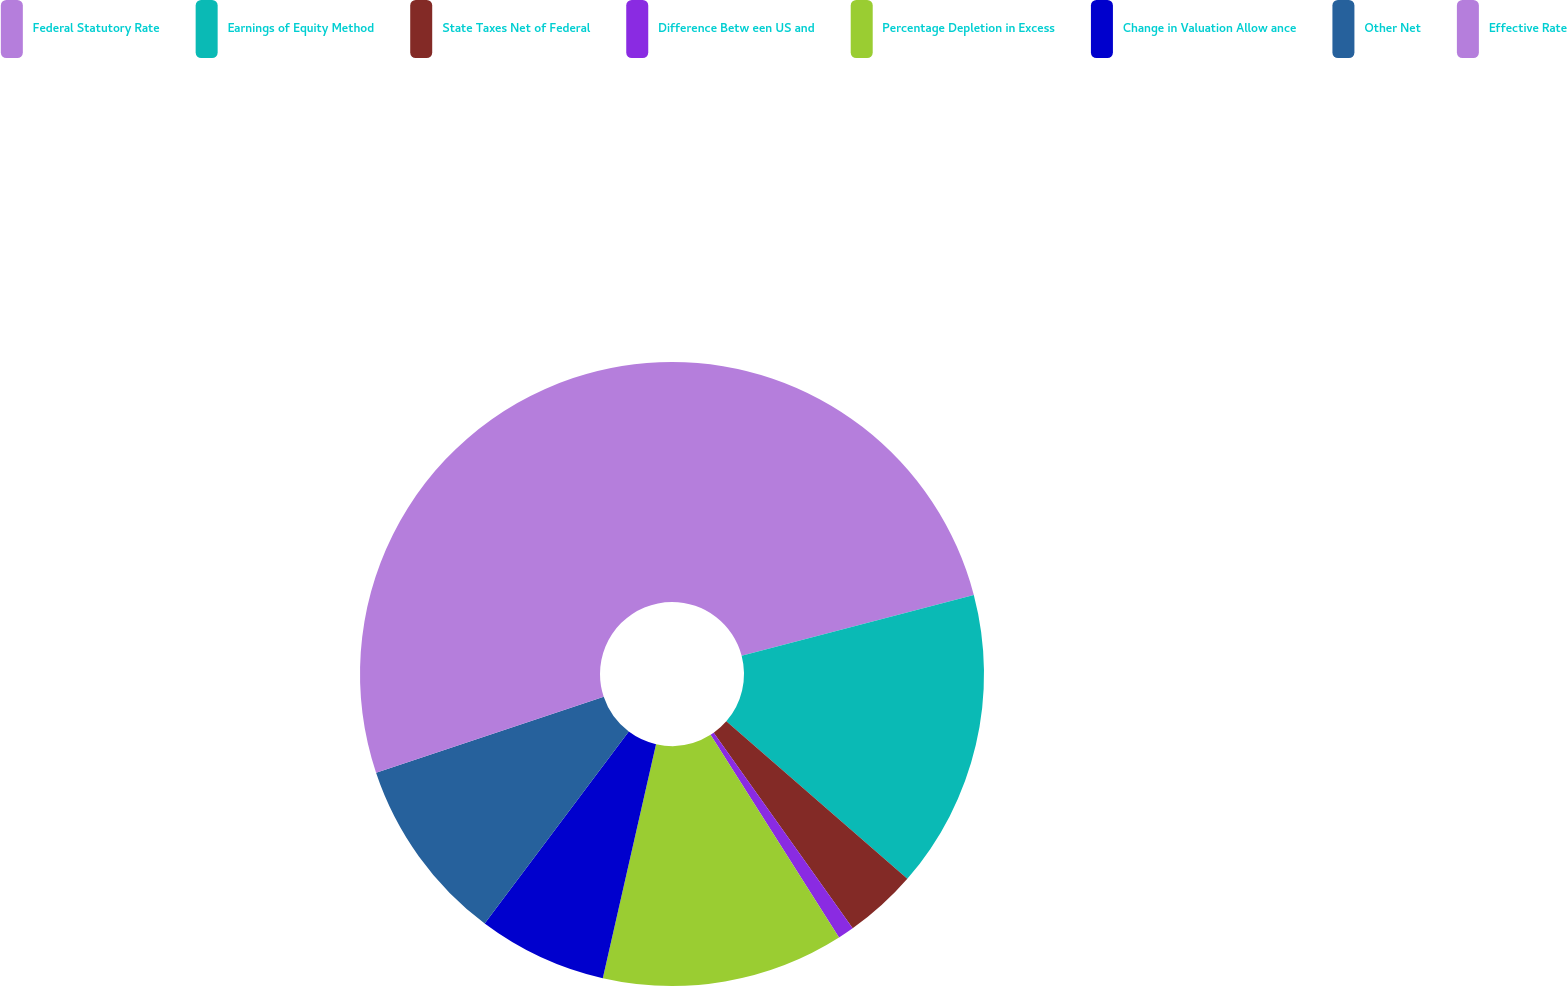Convert chart to OTSL. <chart><loc_0><loc_0><loc_500><loc_500><pie_chart><fcel>Federal Statutory Rate<fcel>Earnings of Equity Method<fcel>State Taxes Net of Federal<fcel>Difference Betw een US and<fcel>Percentage Depletion in Excess<fcel>Change in Valuation Allow ance<fcel>Other Net<fcel>Effective Rate<nl><fcel>20.92%<fcel>15.48%<fcel>3.77%<fcel>0.84%<fcel>12.55%<fcel>6.69%<fcel>9.62%<fcel>30.13%<nl></chart> 